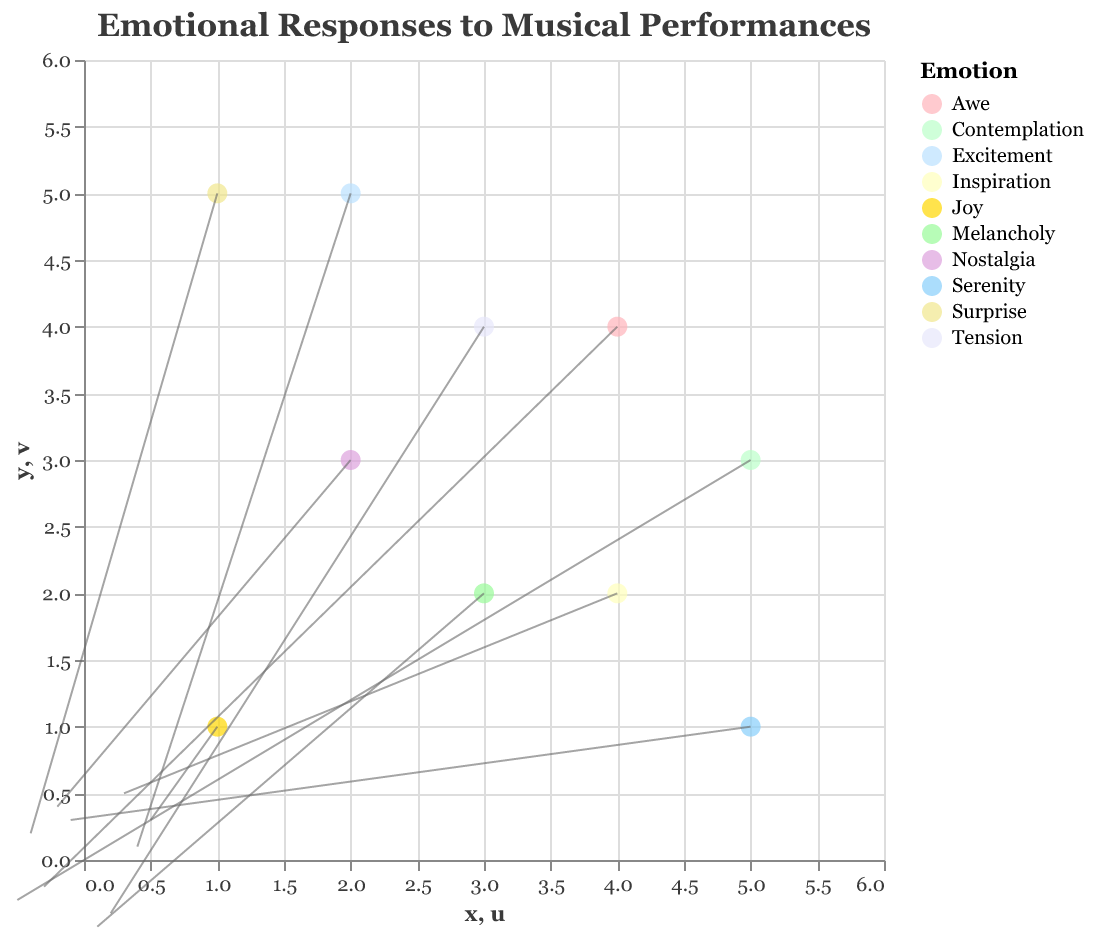What is the title of the figure? The title is usually displayed at the top of the figure in larger and possibly bold font.
Answer: Emotional Responses to Musical Performances How many data points represent "Nostalgia"? Count the number of points in the legend that correspond to "Nostalgia". There is only one data point for "Nostalgia".
Answer: 1 What color represents the emotion "Joy"? Identify the color by looking at the legend that maps emotions to colors. "Joy" is represented by a slightly pinkish color.
Answer: Pink What is the x and y position of the point associated with "Melancholy"? Refer to the tooltip or directly look at the data points in the chart. "Melancholy" is at position (3, 2).
Answer: (3, 2) Which data point shows the largest change in the y-direction? Examine the length of the arrows (v-values) and identify the one with the largest vertical component. "Melancholy" has the largest downward change with a v-value of -0.5.
Answer: "Melancholy" Which emotions have a positive u and v value? Identify data points with both u and v greater than 0 by examining the corresponding arrows. "Joy" and "Inspiration" have positive u and v values.
Answer: Joy, Inspiration How do the directions of the arrows related to "Awe" and "Tension" compare? Compare the directional components (u, v) of the arrows. "Awe" has an arrow with both u and v negative, while "Tension" has u positive and v negative.
Answer: "Awe": both negative, "Tension": mixed What are the average u and v values for the points with "Surprise" and "Excitement"? Calculate the average of the u and v values for these emotions: Surprise: (u = -0.4, v = 0.2), Excitement: (u = 0.4, v = 0.1). Average u = (-0.4 + 0.4)/2 = 0, Average v = (0.2 + 0.1)/2 = 0.15.
Answer: u = 0, v = 0.15 Which data points have arrows pointing towards the lower-left quadrant? Identify arrows with both u and v negative, indicating movement towards the lower left. "Melancholy" and "Contemplation" have arrows pointing towards the lower-left quadrant.
Answer: Melancholy, Contemplation Which emotion shows the greatest movement from (2, 3)? Review the arrows originating from (2, 3) and evaluate their magnitude, "Nostalgia" at (2, 3) shows the greatest move in positive y-direction equal to 0.4.
Answer: Nostalgia 